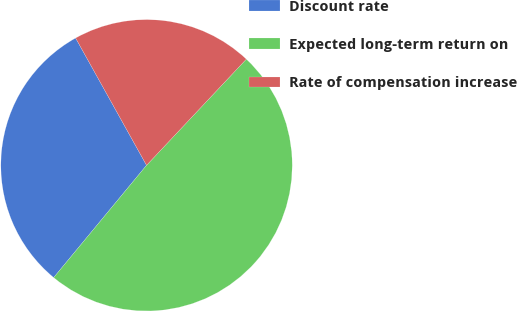Convert chart. <chart><loc_0><loc_0><loc_500><loc_500><pie_chart><fcel>Discount rate<fcel>Expected long-term return on<fcel>Rate of compensation increase<nl><fcel>30.91%<fcel>48.99%<fcel>20.1%<nl></chart> 